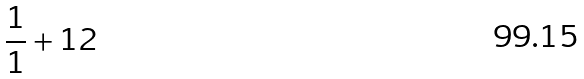<formula> <loc_0><loc_0><loc_500><loc_500>\frac { 1 } { 1 } + 1 2</formula> 